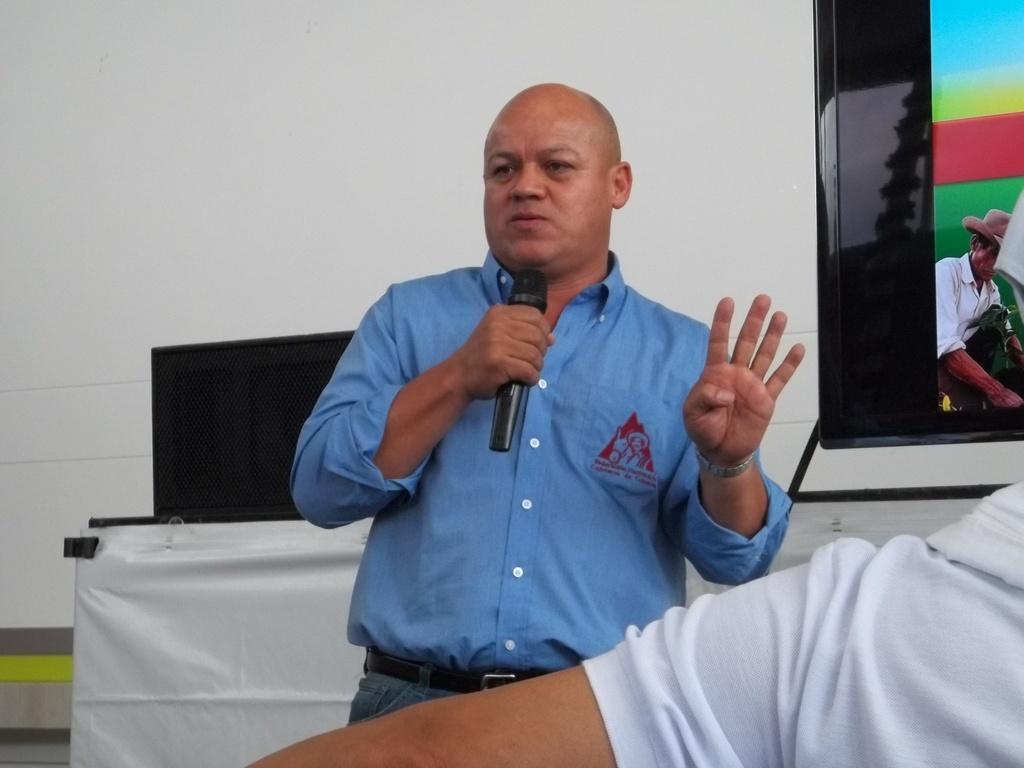Could you give a brief overview of what you see in this image? In this image we can see this person wearing blue shirt is holding a mic and standing on the floor. Here we can see a person's hand. In the background, we can see the monitor, black color object and the white color wall. 